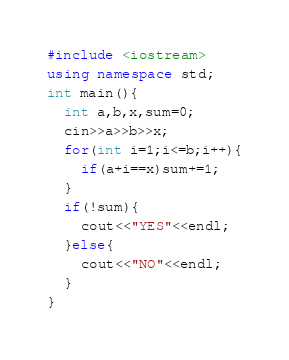<code> <loc_0><loc_0><loc_500><loc_500><_C++_>#include <iostream>
using namespace std;
int main(){
  int a,b,x,sum=0;
  cin>>a>>b>>x;
  for(int i=1;i<=b;i++){
    if(a+i==x)sum+=1;
  }
  if(!sum){
    cout<<"YES"<<endl;
  }else{
    cout<<"NO"<<endl;
  }
}</code> 